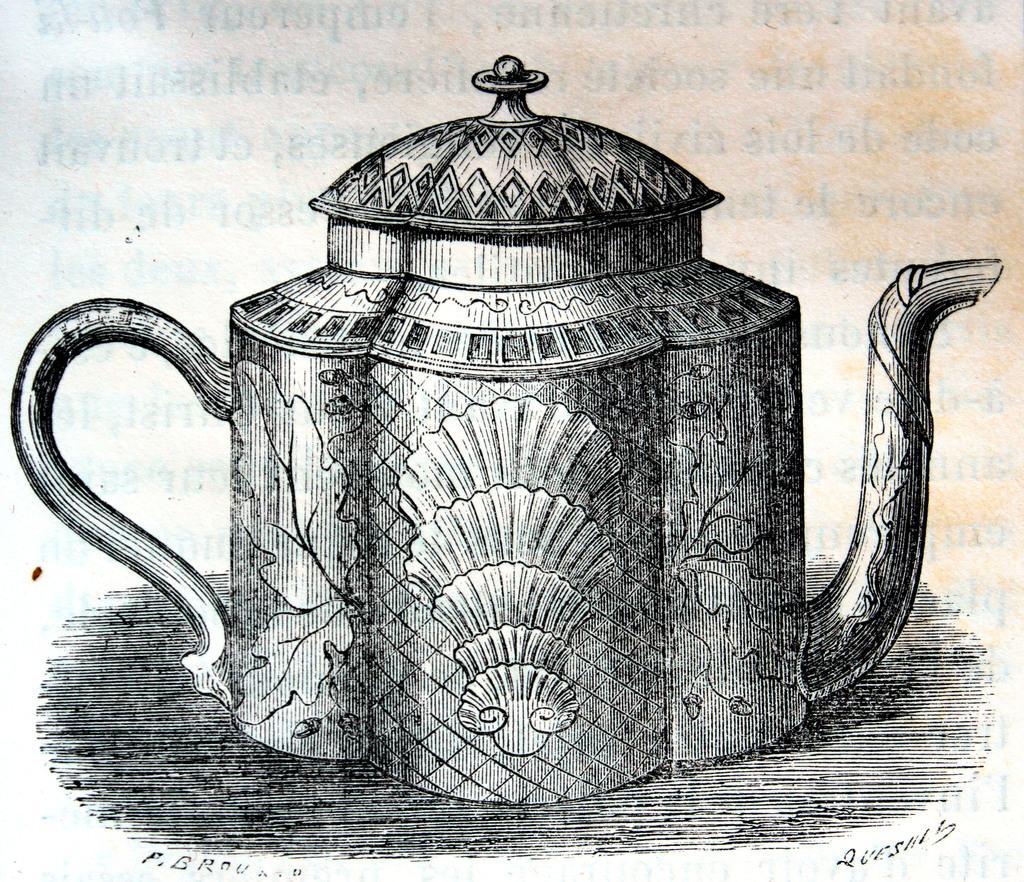Please provide a concise description of this image. This is a picture of paper from a book. In this picture there is a teapot drawing. 